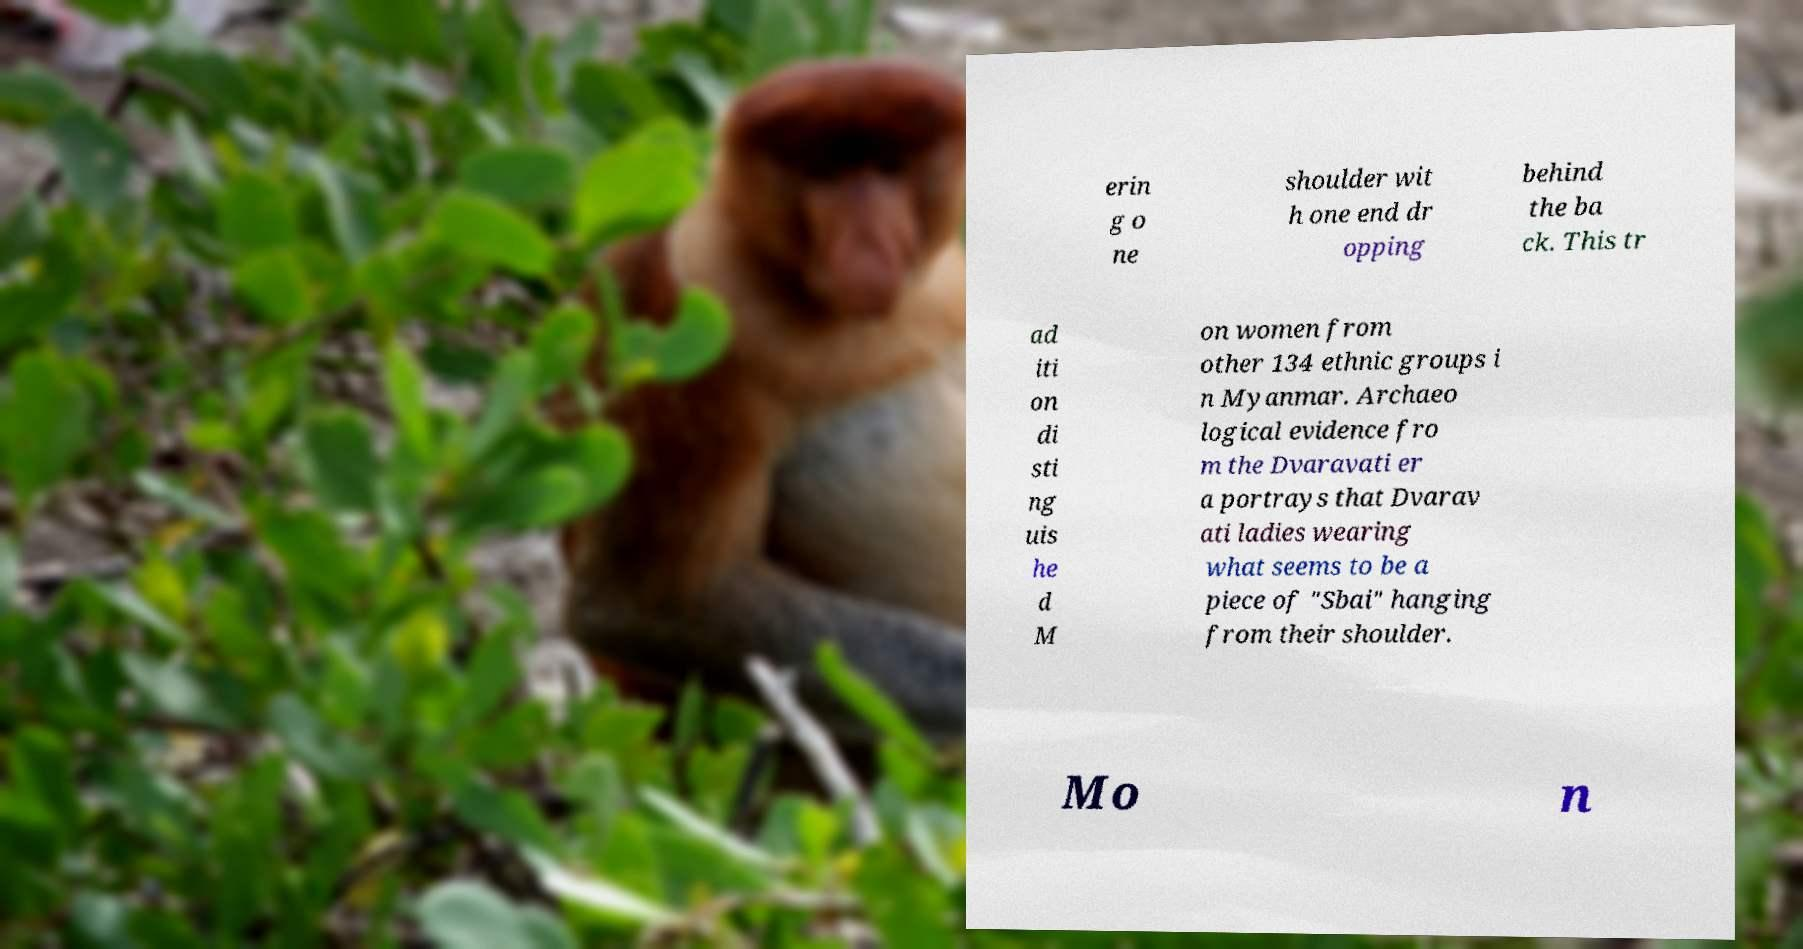For documentation purposes, I need the text within this image transcribed. Could you provide that? erin g o ne shoulder wit h one end dr opping behind the ba ck. This tr ad iti on di sti ng uis he d M on women from other 134 ethnic groups i n Myanmar. Archaeo logical evidence fro m the Dvaravati er a portrays that Dvarav ati ladies wearing what seems to be a piece of "Sbai" hanging from their shoulder. Mo n 